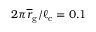Convert formula to latex. <formula><loc_0><loc_0><loc_500><loc_500>2 \pi \overline { r } _ { g } / \ell _ { c } = 0 . 1</formula> 